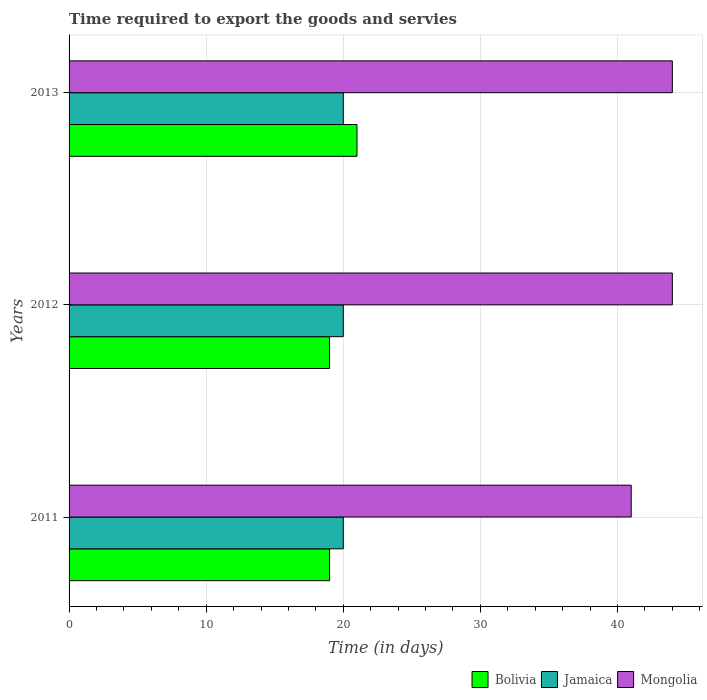How many different coloured bars are there?
Give a very brief answer. 3. How many bars are there on the 2nd tick from the top?
Provide a short and direct response. 3. In how many cases, is the number of bars for a given year not equal to the number of legend labels?
Make the answer very short. 0. What is the number of days required to export the goods and services in Jamaica in 2012?
Give a very brief answer. 20. Across all years, what is the maximum number of days required to export the goods and services in Mongolia?
Give a very brief answer. 44. Across all years, what is the minimum number of days required to export the goods and services in Mongolia?
Provide a succinct answer. 41. In which year was the number of days required to export the goods and services in Jamaica minimum?
Your response must be concise. 2011. What is the total number of days required to export the goods and services in Jamaica in the graph?
Offer a terse response. 60. What is the difference between the number of days required to export the goods and services in Jamaica in 2011 and that in 2013?
Keep it short and to the point. 0. What is the difference between the number of days required to export the goods and services in Bolivia in 2011 and the number of days required to export the goods and services in Jamaica in 2012?
Make the answer very short. -1. What is the average number of days required to export the goods and services in Jamaica per year?
Keep it short and to the point. 20. In the year 2012, what is the difference between the number of days required to export the goods and services in Jamaica and number of days required to export the goods and services in Bolivia?
Your response must be concise. 1. What is the ratio of the number of days required to export the goods and services in Bolivia in 2011 to that in 2012?
Offer a very short reply. 1. Is the difference between the number of days required to export the goods and services in Jamaica in 2012 and 2013 greater than the difference between the number of days required to export the goods and services in Bolivia in 2012 and 2013?
Provide a short and direct response. Yes. What is the difference between the highest and the lowest number of days required to export the goods and services in Mongolia?
Your answer should be compact. 3. Is the sum of the number of days required to export the goods and services in Mongolia in 2011 and 2012 greater than the maximum number of days required to export the goods and services in Jamaica across all years?
Your response must be concise. Yes. What does the 2nd bar from the top in 2012 represents?
Make the answer very short. Jamaica. What does the 3rd bar from the bottom in 2013 represents?
Provide a succinct answer. Mongolia. Is it the case that in every year, the sum of the number of days required to export the goods and services in Bolivia and number of days required to export the goods and services in Mongolia is greater than the number of days required to export the goods and services in Jamaica?
Your response must be concise. Yes. What is the difference between two consecutive major ticks on the X-axis?
Your answer should be very brief. 10. Are the values on the major ticks of X-axis written in scientific E-notation?
Your answer should be compact. No. Does the graph contain any zero values?
Ensure brevity in your answer.  No. Where does the legend appear in the graph?
Ensure brevity in your answer.  Bottom right. What is the title of the graph?
Provide a succinct answer. Time required to export the goods and servies. Does "Afghanistan" appear as one of the legend labels in the graph?
Your answer should be compact. No. What is the label or title of the X-axis?
Make the answer very short. Time (in days). What is the label or title of the Y-axis?
Offer a terse response. Years. What is the Time (in days) in Bolivia in 2012?
Provide a short and direct response. 19. What is the Time (in days) of Mongolia in 2012?
Give a very brief answer. 44. What is the Time (in days) of Bolivia in 2013?
Your answer should be very brief. 21. Across all years, what is the maximum Time (in days) in Mongolia?
Give a very brief answer. 44. Across all years, what is the minimum Time (in days) of Mongolia?
Your answer should be compact. 41. What is the total Time (in days) in Bolivia in the graph?
Offer a terse response. 59. What is the total Time (in days) of Mongolia in the graph?
Keep it short and to the point. 129. What is the difference between the Time (in days) of Mongolia in 2011 and that in 2012?
Offer a very short reply. -3. What is the difference between the Time (in days) in Bolivia in 2011 and that in 2013?
Make the answer very short. -2. What is the difference between the Time (in days) of Mongolia in 2011 and that in 2013?
Provide a succinct answer. -3. What is the difference between the Time (in days) of Bolivia in 2012 and that in 2013?
Your response must be concise. -2. What is the difference between the Time (in days) in Jamaica in 2012 and that in 2013?
Your answer should be very brief. 0. What is the difference between the Time (in days) in Mongolia in 2012 and that in 2013?
Ensure brevity in your answer.  0. What is the difference between the Time (in days) in Bolivia in 2011 and the Time (in days) in Mongolia in 2012?
Ensure brevity in your answer.  -25. What is the difference between the Time (in days) of Jamaica in 2011 and the Time (in days) of Mongolia in 2012?
Make the answer very short. -24. What is the difference between the Time (in days) in Bolivia in 2012 and the Time (in days) in Jamaica in 2013?
Give a very brief answer. -1. What is the difference between the Time (in days) in Jamaica in 2012 and the Time (in days) in Mongolia in 2013?
Offer a terse response. -24. What is the average Time (in days) in Bolivia per year?
Offer a terse response. 19.67. What is the average Time (in days) of Mongolia per year?
Give a very brief answer. 43. In the year 2011, what is the difference between the Time (in days) of Bolivia and Time (in days) of Jamaica?
Offer a very short reply. -1. In the year 2012, what is the difference between the Time (in days) in Jamaica and Time (in days) in Mongolia?
Ensure brevity in your answer.  -24. In the year 2013, what is the difference between the Time (in days) in Jamaica and Time (in days) in Mongolia?
Ensure brevity in your answer.  -24. What is the ratio of the Time (in days) of Bolivia in 2011 to that in 2012?
Your answer should be compact. 1. What is the ratio of the Time (in days) of Jamaica in 2011 to that in 2012?
Ensure brevity in your answer.  1. What is the ratio of the Time (in days) in Mongolia in 2011 to that in 2012?
Make the answer very short. 0.93. What is the ratio of the Time (in days) in Bolivia in 2011 to that in 2013?
Keep it short and to the point. 0.9. What is the ratio of the Time (in days) in Jamaica in 2011 to that in 2013?
Your answer should be very brief. 1. What is the ratio of the Time (in days) of Mongolia in 2011 to that in 2013?
Keep it short and to the point. 0.93. What is the ratio of the Time (in days) of Bolivia in 2012 to that in 2013?
Offer a very short reply. 0.9. What is the ratio of the Time (in days) of Jamaica in 2012 to that in 2013?
Your answer should be very brief. 1. What is the ratio of the Time (in days) of Mongolia in 2012 to that in 2013?
Your answer should be compact. 1. What is the difference between the highest and the second highest Time (in days) of Jamaica?
Offer a very short reply. 0. What is the difference between the highest and the lowest Time (in days) in Jamaica?
Your answer should be very brief. 0. What is the difference between the highest and the lowest Time (in days) in Mongolia?
Ensure brevity in your answer.  3. 